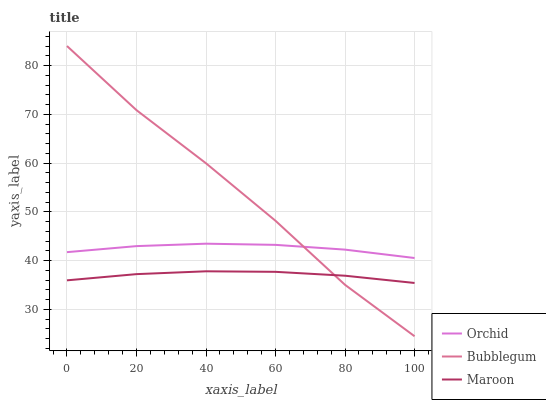Does Maroon have the minimum area under the curve?
Answer yes or no. Yes. Does Bubblegum have the maximum area under the curve?
Answer yes or no. Yes. Does Orchid have the minimum area under the curve?
Answer yes or no. No. Does Orchid have the maximum area under the curve?
Answer yes or no. No. Is Maroon the smoothest?
Answer yes or no. Yes. Is Bubblegum the roughest?
Answer yes or no. Yes. Is Orchid the smoothest?
Answer yes or no. No. Is Orchid the roughest?
Answer yes or no. No. Does Orchid have the lowest value?
Answer yes or no. No. Does Bubblegum have the highest value?
Answer yes or no. Yes. Does Orchid have the highest value?
Answer yes or no. No. Is Maroon less than Orchid?
Answer yes or no. Yes. Is Orchid greater than Maroon?
Answer yes or no. Yes. Does Orchid intersect Bubblegum?
Answer yes or no. Yes. Is Orchid less than Bubblegum?
Answer yes or no. No. Is Orchid greater than Bubblegum?
Answer yes or no. No. Does Maroon intersect Orchid?
Answer yes or no. No. 